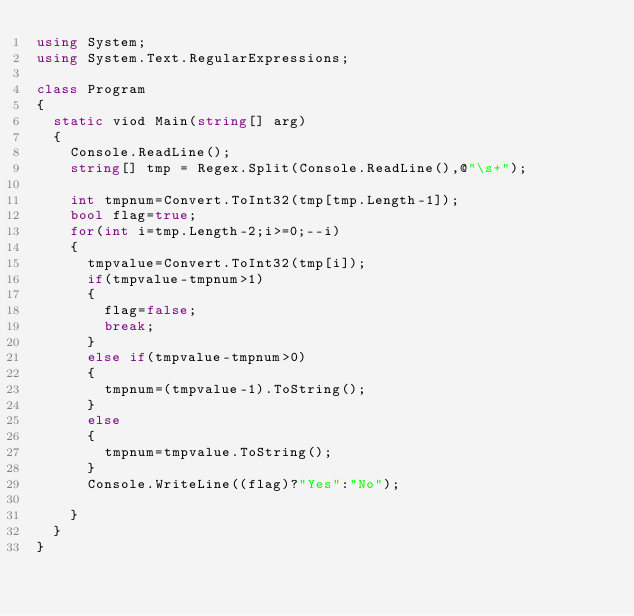<code> <loc_0><loc_0><loc_500><loc_500><_C#_>using System;
using System.Text.RegularExpressions;

class Program
{
  static viod Main(string[] arg)
  {
    Console.ReadLine();
    string[] tmp = Regex.Split(Console.ReadLine(),@"\s+");
    
    int tmpnum=Convert.ToInt32(tmp[tmp.Length-1]);
    bool flag=true;
    for(int i=tmp.Length-2;i>=0;--i)
    {
      tmpvalue=Convert.ToInt32(tmp[i]);
      if(tmpvalue-tmpnum>1)
      {
        flag=false;
        break;
      }
      else if(tmpvalue-tmpnum>0)
      {
        tmpnum=(tmpvalue-1).ToString();
      }
      else
      {
        tmpnum=tmpvalue.ToString();
      }
      Console.WriteLine((flag)?"Yes":"No");
      
    }
  }
}</code> 